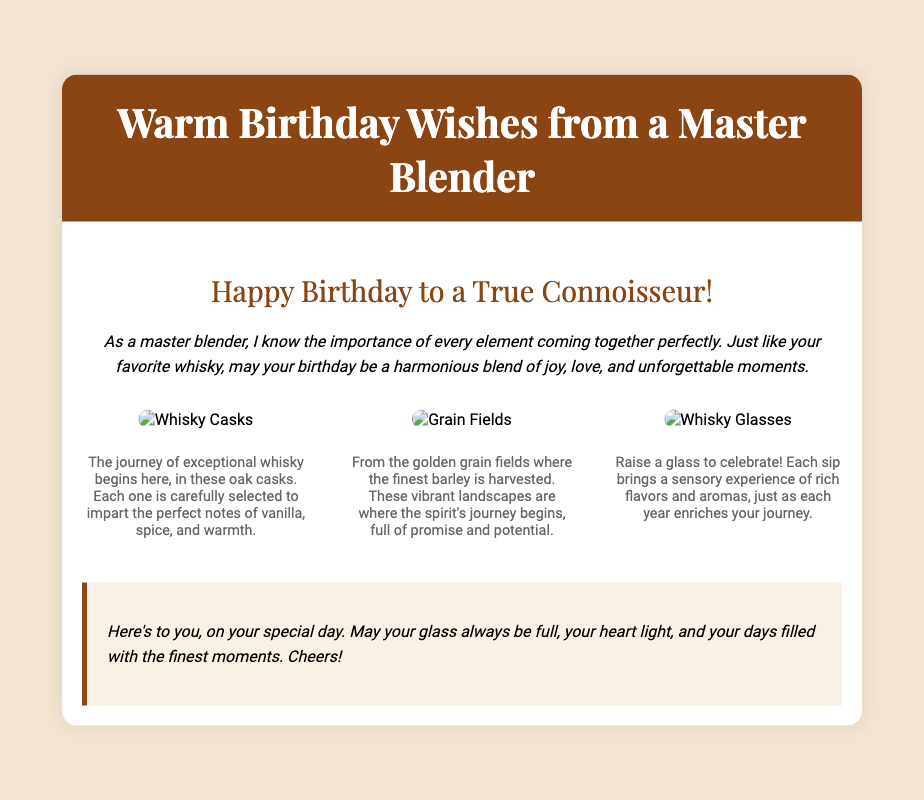What is the title of the card? The title is prominently displayed in the header section of the card.
Answer: Warm Birthday Wishes from a Master Blender Who is the card addressed to? The greeting specifically addresses a "True Connoisseur," indicating its intended recipient.
Answer: A True Connoisseur What is depicted in the first illustration? The first illustration is described in the content section regarding whisky casks.
Answer: Whisky Casks What is the main color scheme of the card? The background color and header color give insight into the predominant colors used throughout the card.
Answer: Brown and cream What does the personal note express? The personal note provides a special message that conveys best wishes and sentiments for the birthday person.
Answer: Cheers! What types of elements are illustrated in the card? The illustrations encompass specific items related to whisky production and celebration.
Answer: Casks, grain fields, whisky glasses How many images are included in the card? The document describes the image section, indicating the number of images present.
Answer: Three images What sensory experience does the card emphasize regarding whisky? The card highlights specific attributes that contribute to the experience of tasting whisky.
Answer: Rich flavors and aromas What emotion is the card designed to convey? The introductory message and personal note suggest the overall feeling intended with the card.
Answer: Joy and love 